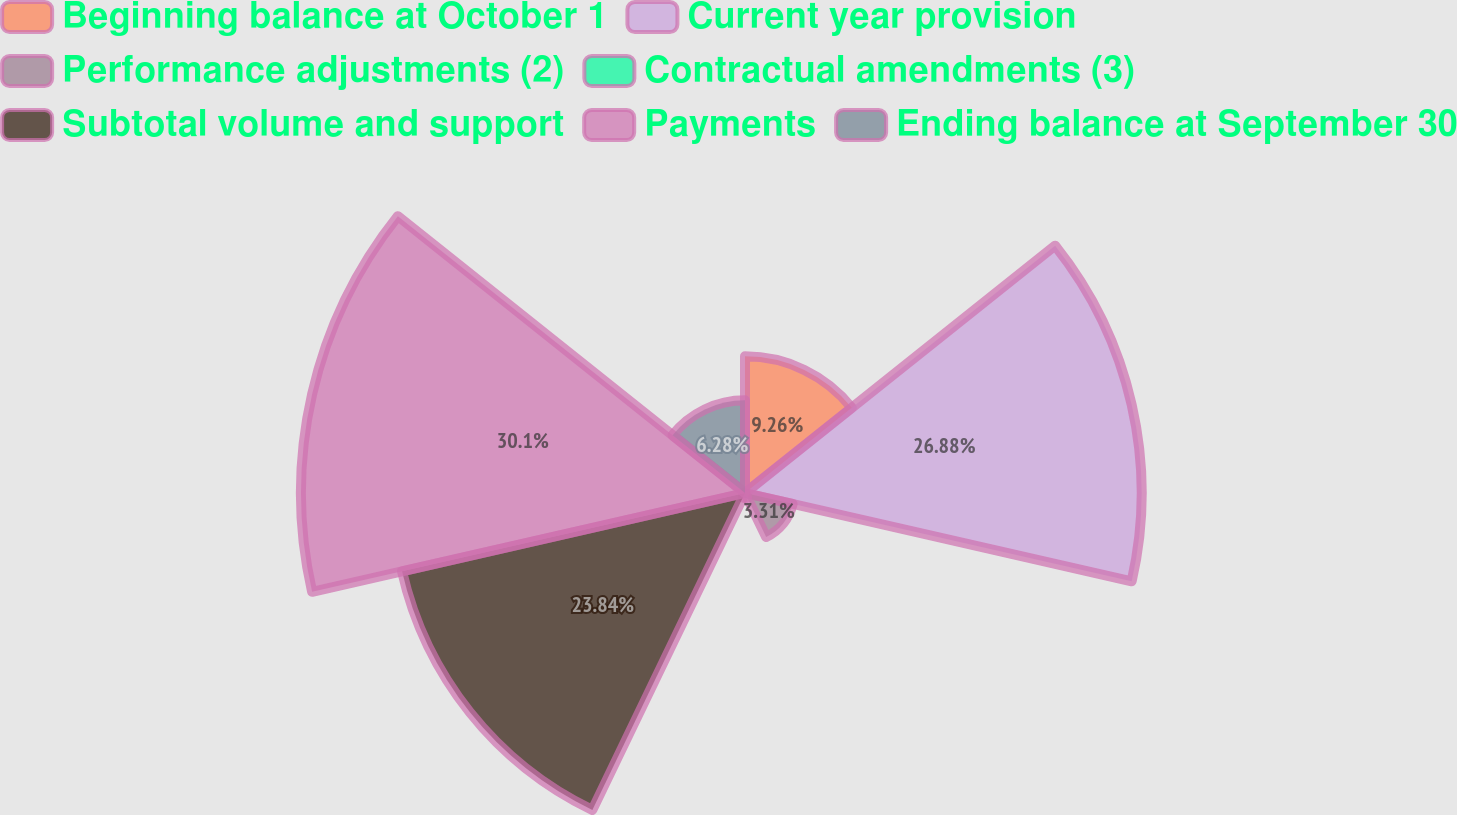<chart> <loc_0><loc_0><loc_500><loc_500><pie_chart><fcel>Beginning balance at October 1<fcel>Current year provision<fcel>Performance adjustments (2)<fcel>Contractual amendments (3)<fcel>Subtotal volume and support<fcel>Payments<fcel>Ending balance at September 30<nl><fcel>9.26%<fcel>26.88%<fcel>3.31%<fcel>0.33%<fcel>23.84%<fcel>30.09%<fcel>6.28%<nl></chart> 